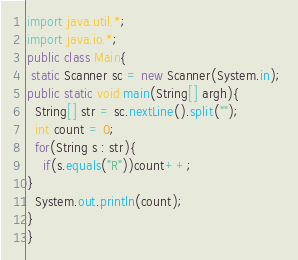<code> <loc_0><loc_0><loc_500><loc_500><_Java_>import java.util.*;
import java.io.*;
public class Main{
 static Scanner sc = new Scanner(System.in); 
public static void main(String[] argh){
  String[] str = sc.nextLine().split("");
  int count = 0;
  for(String s : str){
    if(s.equals("R"))count++;
}
  System.out.println(count);
}
}
</code> 